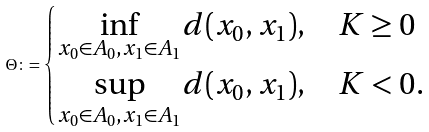Convert formula to latex. <formula><loc_0><loc_0><loc_500><loc_500>\Theta \colon = \begin{cases} \underset { x _ { 0 } \in A _ { 0 } , x _ { 1 } \in A _ { 1 } } { \inf } d ( x _ { 0 } , x _ { 1 } ) , & K \geq 0 \\ \underset { x _ { 0 } \in A _ { 0 } , x _ { 1 } \in A _ { 1 } } { \sup } d ( x _ { 0 } , x _ { 1 } ) , & K < 0 . \end{cases}</formula> 